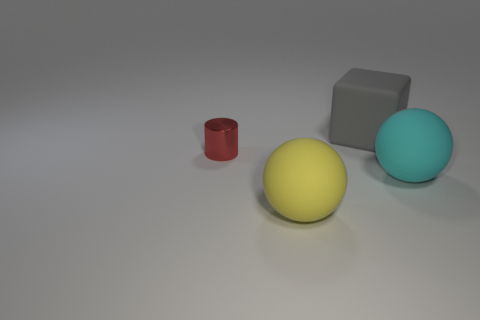Subtract all purple balls. Subtract all gray blocks. How many balls are left? 2 Subtract all yellow balls. How many blue cylinders are left? 0 Add 4 big grays. How many tiny objects exist? 0 Subtract all small purple cylinders. Subtract all tiny metallic cylinders. How many objects are left? 3 Add 4 small red things. How many small red things are left? 5 Add 4 cylinders. How many cylinders exist? 5 Add 1 purple things. How many objects exist? 5 Subtract all yellow spheres. How many spheres are left? 1 Subtract 1 red cylinders. How many objects are left? 3 Subtract all blocks. How many objects are left? 3 